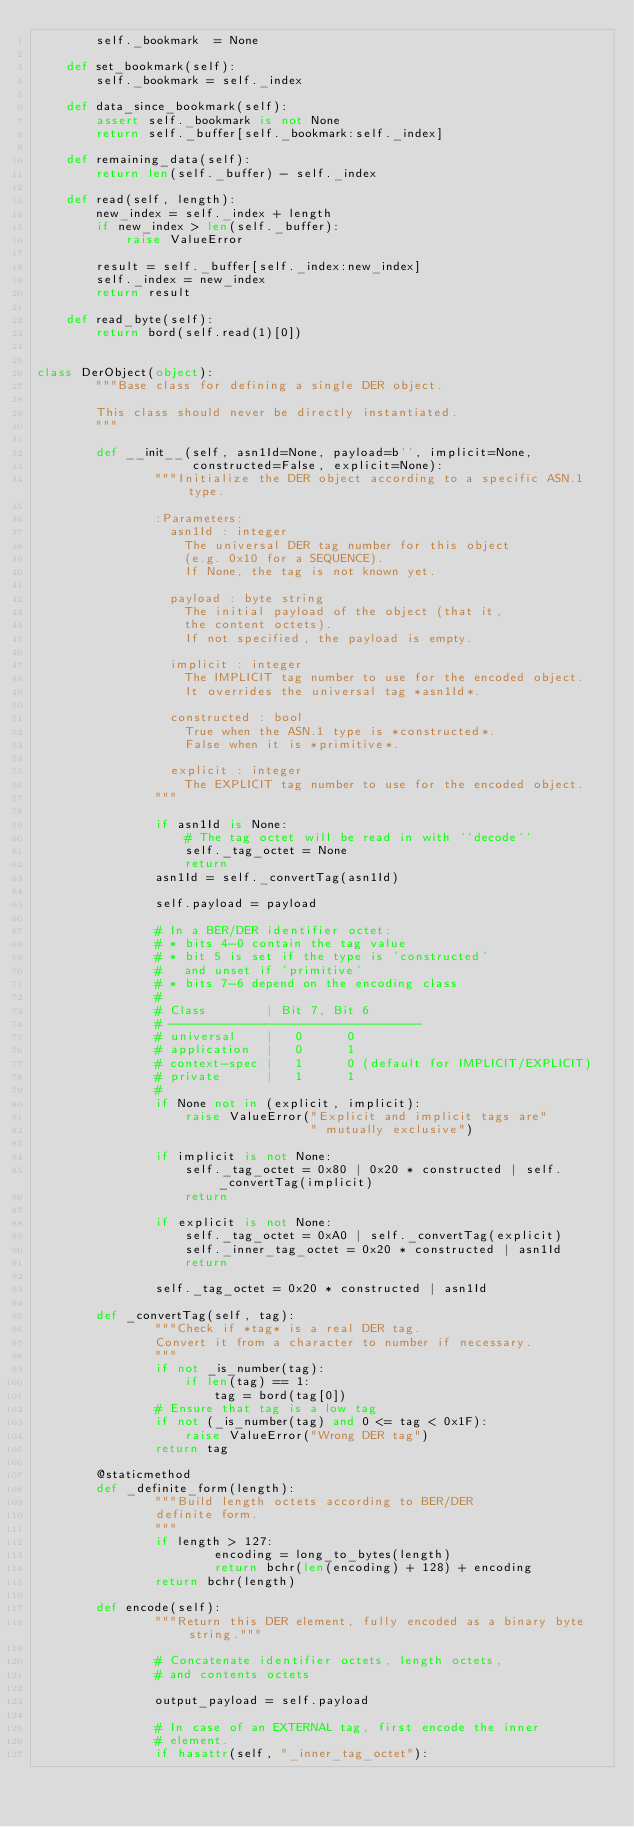<code> <loc_0><loc_0><loc_500><loc_500><_Python_>        self._bookmark  = None

    def set_bookmark(self):
        self._bookmark = self._index

    def data_since_bookmark(self):
        assert self._bookmark is not None
        return self._buffer[self._bookmark:self._index]

    def remaining_data(self):
        return len(self._buffer) - self._index

    def read(self, length):
        new_index = self._index + length
        if new_index > len(self._buffer):
            raise ValueError

        result = self._buffer[self._index:new_index]
        self._index = new_index
        return result

    def read_byte(self):
        return bord(self.read(1)[0])


class DerObject(object):
        """Base class for defining a single DER object.

        This class should never be directly instantiated.
        """

        def __init__(self, asn1Id=None, payload=b'', implicit=None,
                     constructed=False, explicit=None):
                """Initialize the DER object according to a specific ASN.1 type.

                :Parameters:
                  asn1Id : integer
                    The universal DER tag number for this object
                    (e.g. 0x10 for a SEQUENCE).
                    If None, the tag is not known yet.

                  payload : byte string
                    The initial payload of the object (that it,
                    the content octets).
                    If not specified, the payload is empty.

                  implicit : integer
                    The IMPLICIT tag number to use for the encoded object.
                    It overrides the universal tag *asn1Id*.

                  constructed : bool
                    True when the ASN.1 type is *constructed*.
                    False when it is *primitive*.

                  explicit : integer
                    The EXPLICIT tag number to use for the encoded object.
                """

                if asn1Id is None:
                    # The tag octet will be read in with ``decode``
                    self._tag_octet = None
                    return
                asn1Id = self._convertTag(asn1Id)

                self.payload = payload

                # In a BER/DER identifier octet:
                # * bits 4-0 contain the tag value
                # * bit 5 is set if the type is 'constructed'
                #   and unset if 'primitive'
                # * bits 7-6 depend on the encoding class
                #
                # Class        | Bit 7, Bit 6
                # ----------------------------------
                # universal    |   0      0
                # application  |   0      1
                # context-spec |   1      0 (default for IMPLICIT/EXPLICIT)
                # private      |   1      1
                #
                if None not in (explicit, implicit):
                    raise ValueError("Explicit and implicit tags are"
                                     " mutually exclusive")

                if implicit is not None:
                    self._tag_octet = 0x80 | 0x20 * constructed | self._convertTag(implicit)
                    return

                if explicit is not None:
                    self._tag_octet = 0xA0 | self._convertTag(explicit)
                    self._inner_tag_octet = 0x20 * constructed | asn1Id
                    return
                
                self._tag_octet = 0x20 * constructed | asn1Id

        def _convertTag(self, tag):
                """Check if *tag* is a real DER tag.
                Convert it from a character to number if necessary.
                """
                if not _is_number(tag):
                    if len(tag) == 1:
                        tag = bord(tag[0])
                # Ensure that tag is a low tag
                if not (_is_number(tag) and 0 <= tag < 0x1F):
                    raise ValueError("Wrong DER tag")
                return tag

        @staticmethod
        def _definite_form(length):
                """Build length octets according to BER/DER
                definite form.
                """
                if length > 127:
                        encoding = long_to_bytes(length)
                        return bchr(len(encoding) + 128) + encoding
                return bchr(length)

        def encode(self):
                """Return this DER element, fully encoded as a binary byte string."""

                # Concatenate identifier octets, length octets,
                # and contents octets

                output_payload = self.payload

                # In case of an EXTERNAL tag, first encode the inner
                # element.
                if hasattr(self, "_inner_tag_octet"):</code> 